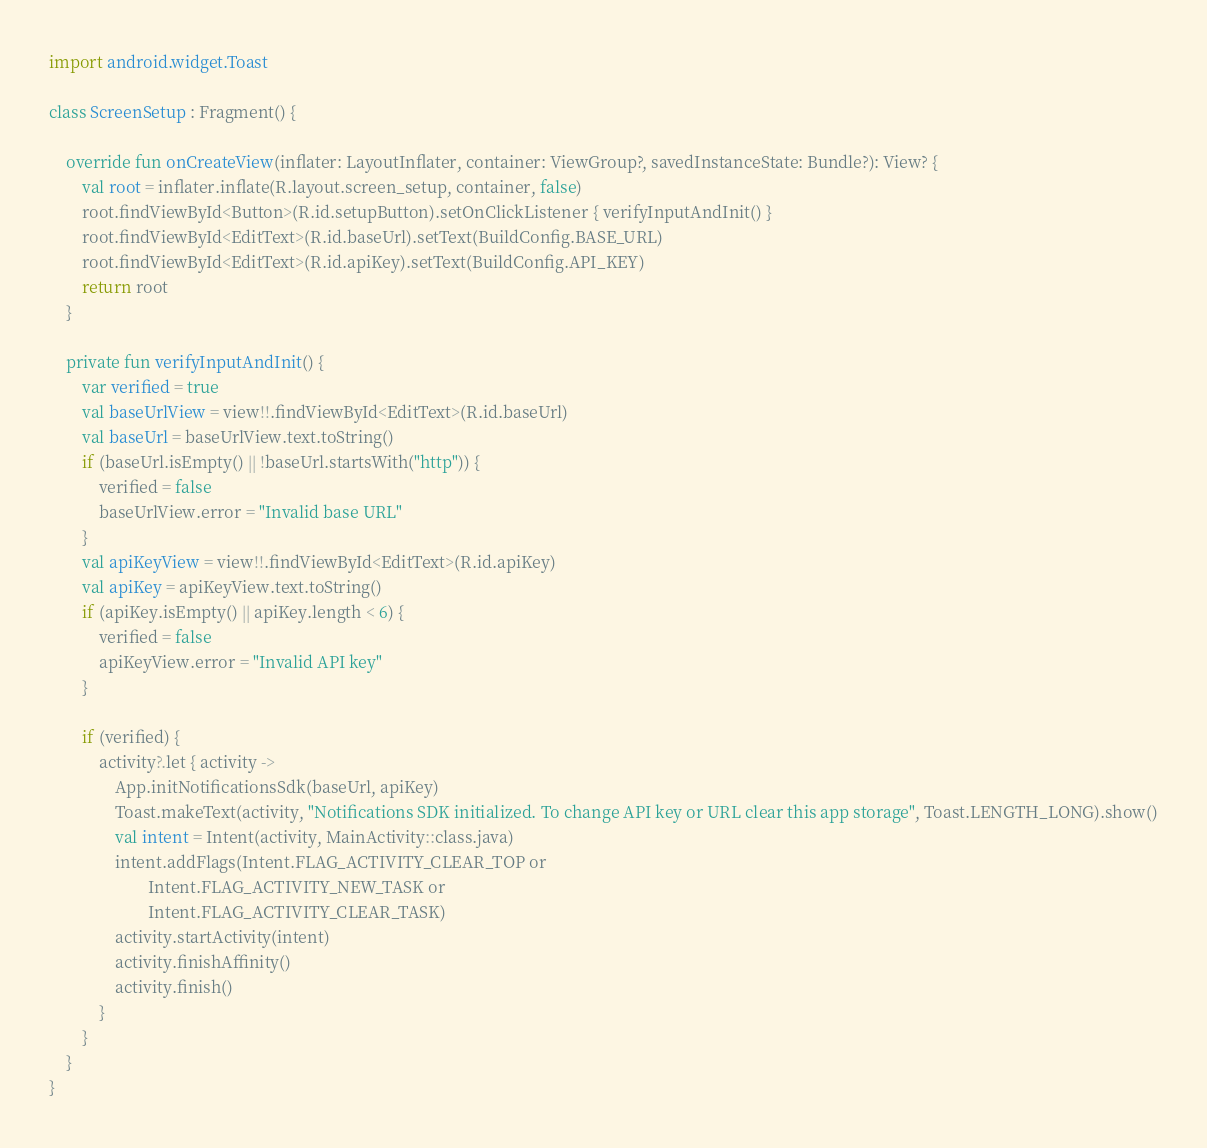<code> <loc_0><loc_0><loc_500><loc_500><_Kotlin_>import android.widget.Toast

class ScreenSetup : Fragment() {

    override fun onCreateView(inflater: LayoutInflater, container: ViewGroup?, savedInstanceState: Bundle?): View? {
        val root = inflater.inflate(R.layout.screen_setup, container, false)
        root.findViewById<Button>(R.id.setupButton).setOnClickListener { verifyInputAndInit() }
        root.findViewById<EditText>(R.id.baseUrl).setText(BuildConfig.BASE_URL)
        root.findViewById<EditText>(R.id.apiKey).setText(BuildConfig.API_KEY)
        return root
    }

    private fun verifyInputAndInit() {
        var verified = true
        val baseUrlView = view!!.findViewById<EditText>(R.id.baseUrl)
        val baseUrl = baseUrlView.text.toString()
        if (baseUrl.isEmpty() || !baseUrl.startsWith("http")) {
            verified = false
            baseUrlView.error = "Invalid base URL"
        }
        val apiKeyView = view!!.findViewById<EditText>(R.id.apiKey)
        val apiKey = apiKeyView.text.toString()
        if (apiKey.isEmpty() || apiKey.length < 6) {
            verified = false
            apiKeyView.error = "Invalid API key"
        }

        if (verified) {
            activity?.let { activity ->
                App.initNotificationsSdk(baseUrl, apiKey)
                Toast.makeText(activity, "Notifications SDK initialized. To change API key or URL clear this app storage", Toast.LENGTH_LONG).show()
                val intent = Intent(activity, MainActivity::class.java)
                intent.addFlags(Intent.FLAG_ACTIVITY_CLEAR_TOP or
                        Intent.FLAG_ACTIVITY_NEW_TASK or
                        Intent.FLAG_ACTIVITY_CLEAR_TASK)
                activity.startActivity(intent)
                activity.finishAffinity()
                activity.finish()
            }
        }
    }
}</code> 